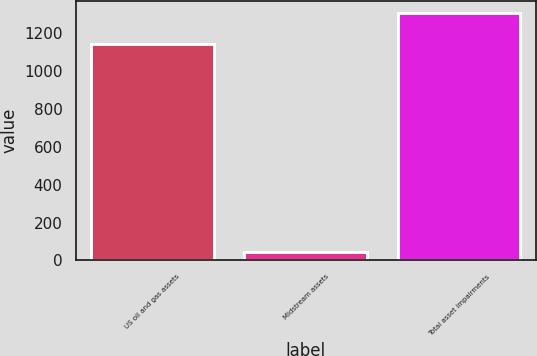<chart> <loc_0><loc_0><loc_500><loc_500><bar_chart><fcel>US oil and gas assets<fcel>Midstream assets<fcel>Total asset impairments<nl><fcel>1142<fcel>44<fcel>1308<nl></chart> 